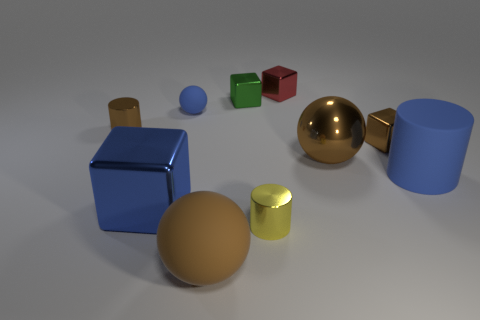Subtract all purple blocks. Subtract all red cylinders. How many blocks are left? 4 Subtract all spheres. How many objects are left? 7 Subtract 0 purple cylinders. How many objects are left? 10 Subtract all green metallic objects. Subtract all rubber cylinders. How many objects are left? 8 Add 3 brown objects. How many brown objects are left? 7 Add 7 tiny yellow cylinders. How many tiny yellow cylinders exist? 8 